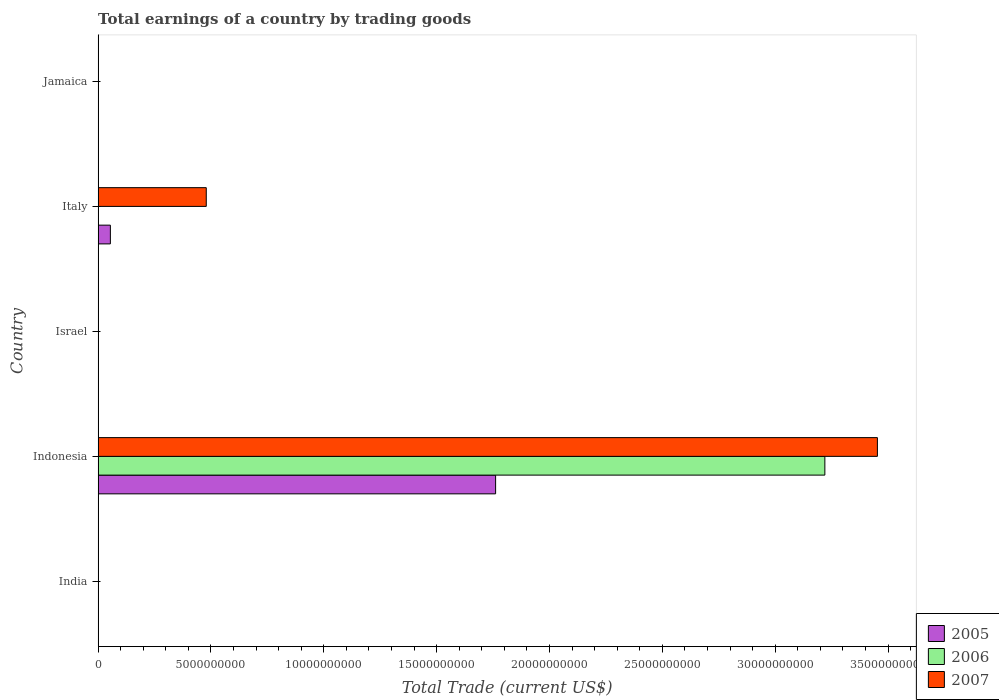How many different coloured bars are there?
Your answer should be compact. 3. What is the label of the 5th group of bars from the top?
Offer a terse response. India. What is the total earnings in 2005 in Indonesia?
Provide a succinct answer. 1.76e+1. Across all countries, what is the maximum total earnings in 2007?
Your response must be concise. 3.45e+1. Across all countries, what is the minimum total earnings in 2006?
Give a very brief answer. 0. What is the total total earnings in 2006 in the graph?
Your response must be concise. 3.22e+1. What is the average total earnings in 2005 per country?
Provide a short and direct response. 3.63e+09. What is the difference between the total earnings in 2005 and total earnings in 2007 in Indonesia?
Provide a succinct answer. -1.69e+1. What is the difference between the highest and the lowest total earnings in 2006?
Offer a very short reply. 3.22e+1. Are all the bars in the graph horizontal?
Your answer should be very brief. Yes. Are the values on the major ticks of X-axis written in scientific E-notation?
Keep it short and to the point. No. Does the graph contain any zero values?
Your answer should be compact. Yes. Where does the legend appear in the graph?
Keep it short and to the point. Bottom right. What is the title of the graph?
Make the answer very short. Total earnings of a country by trading goods. Does "1987" appear as one of the legend labels in the graph?
Ensure brevity in your answer.  No. What is the label or title of the X-axis?
Your answer should be very brief. Total Trade (current US$). What is the Total Trade (current US$) in 2007 in India?
Provide a short and direct response. 0. What is the Total Trade (current US$) in 2005 in Indonesia?
Provide a short and direct response. 1.76e+1. What is the Total Trade (current US$) of 2006 in Indonesia?
Offer a terse response. 3.22e+1. What is the Total Trade (current US$) of 2007 in Indonesia?
Make the answer very short. 3.45e+1. What is the Total Trade (current US$) of 2005 in Israel?
Make the answer very short. 0. What is the Total Trade (current US$) in 2005 in Italy?
Your answer should be very brief. 5.43e+08. What is the Total Trade (current US$) in 2006 in Italy?
Keep it short and to the point. 0. What is the Total Trade (current US$) of 2007 in Italy?
Make the answer very short. 4.79e+09. What is the Total Trade (current US$) of 2006 in Jamaica?
Give a very brief answer. 0. Across all countries, what is the maximum Total Trade (current US$) of 2005?
Offer a very short reply. 1.76e+1. Across all countries, what is the maximum Total Trade (current US$) in 2006?
Provide a succinct answer. 3.22e+1. Across all countries, what is the maximum Total Trade (current US$) in 2007?
Provide a succinct answer. 3.45e+1. Across all countries, what is the minimum Total Trade (current US$) of 2005?
Your answer should be very brief. 0. Across all countries, what is the minimum Total Trade (current US$) of 2007?
Make the answer very short. 0. What is the total Total Trade (current US$) of 2005 in the graph?
Provide a short and direct response. 1.82e+1. What is the total Total Trade (current US$) in 2006 in the graph?
Offer a terse response. 3.22e+1. What is the total Total Trade (current US$) in 2007 in the graph?
Make the answer very short. 3.93e+1. What is the difference between the Total Trade (current US$) in 2005 in Indonesia and that in Italy?
Offer a very short reply. 1.71e+1. What is the difference between the Total Trade (current US$) of 2007 in Indonesia and that in Italy?
Give a very brief answer. 2.97e+1. What is the difference between the Total Trade (current US$) of 2005 in Indonesia and the Total Trade (current US$) of 2007 in Italy?
Keep it short and to the point. 1.28e+1. What is the difference between the Total Trade (current US$) of 2006 in Indonesia and the Total Trade (current US$) of 2007 in Italy?
Offer a very short reply. 2.74e+1. What is the average Total Trade (current US$) in 2005 per country?
Offer a terse response. 3.63e+09. What is the average Total Trade (current US$) of 2006 per country?
Your answer should be very brief. 6.44e+09. What is the average Total Trade (current US$) in 2007 per country?
Ensure brevity in your answer.  7.86e+09. What is the difference between the Total Trade (current US$) in 2005 and Total Trade (current US$) in 2006 in Indonesia?
Your answer should be very brief. -1.46e+1. What is the difference between the Total Trade (current US$) of 2005 and Total Trade (current US$) of 2007 in Indonesia?
Your answer should be very brief. -1.69e+1. What is the difference between the Total Trade (current US$) in 2006 and Total Trade (current US$) in 2007 in Indonesia?
Provide a succinct answer. -2.33e+09. What is the difference between the Total Trade (current US$) in 2005 and Total Trade (current US$) in 2007 in Italy?
Your answer should be compact. -4.25e+09. What is the ratio of the Total Trade (current US$) of 2005 in Indonesia to that in Italy?
Offer a terse response. 32.45. What is the ratio of the Total Trade (current US$) in 2007 in Indonesia to that in Italy?
Provide a succinct answer. 7.21. What is the difference between the highest and the lowest Total Trade (current US$) in 2005?
Your response must be concise. 1.76e+1. What is the difference between the highest and the lowest Total Trade (current US$) in 2006?
Your answer should be compact. 3.22e+1. What is the difference between the highest and the lowest Total Trade (current US$) in 2007?
Your answer should be very brief. 3.45e+1. 